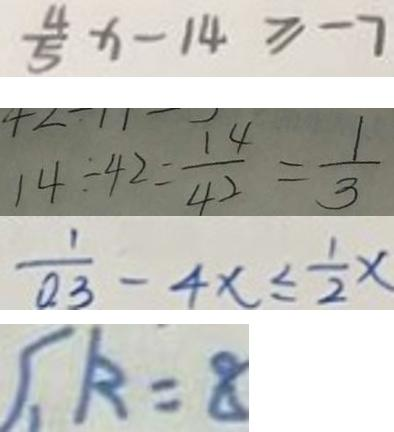Convert formula to latex. <formula><loc_0><loc_0><loc_500><loc_500>\frac { 4 } { 5 } x - 1 4 \geq - 7 
 1 4 \div 4 2 = \frac { 1 4 } { 4 2 } = \frac { 1 } { 3 } 
 \frac { 1 } { 0 . 3 } - 4 x \leq \frac { 1 } { 2 } x 
 k = 8</formula> 